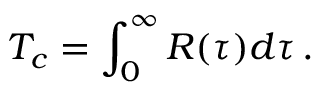<formula> <loc_0><loc_0><loc_500><loc_500>T _ { c } = \int _ { 0 } ^ { \infty } R ( \tau ) d \tau \, .</formula> 